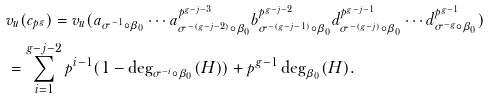Convert formula to latex. <formula><loc_0><loc_0><loc_500><loc_500>& v _ { u } ( c _ { p ^ { g } } ) = v _ { u } ( a _ { \sigma ^ { - 1 } \circ \beta _ { 0 } } \cdots a _ { \sigma ^ { - ( g - j - 2 ) } \circ \beta _ { 0 } } ^ { p ^ { g - j - 3 } } b _ { \sigma ^ { - ( g - j - 1 ) } \circ \beta _ { 0 } } ^ { p ^ { g - j - 2 } } d _ { \sigma ^ { - ( g - j ) } \circ \beta _ { 0 } } ^ { p ^ { g - j - 1 } } \cdots d _ { \sigma ^ { - g } \circ \beta _ { 0 } } ^ { p ^ { g - 1 } } ) \\ & = \sum _ { i = 1 } ^ { g - j - 2 } p ^ { i - 1 } ( 1 - \deg _ { \sigma ^ { - i } \circ \beta _ { 0 } } ( H ) ) + p ^ { g - 1 } \deg _ { \beta _ { 0 } } ( H ) .</formula> 